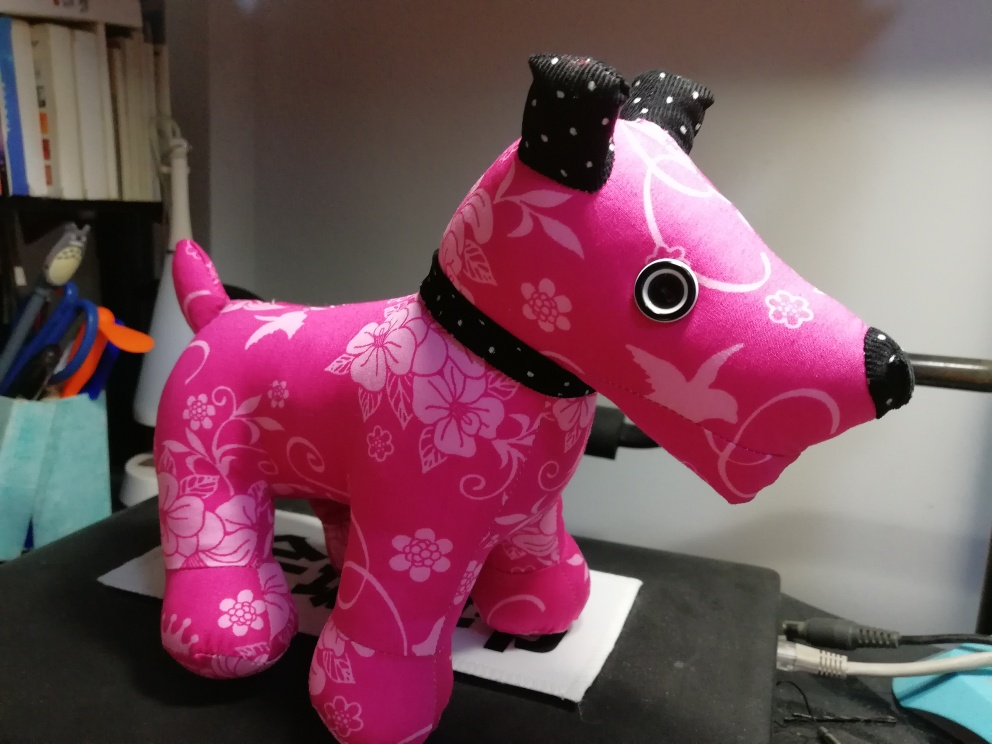Could you describe the design elements seen on this object? Certainly! The object features a floral motif with various flower shapes in a lighter shade of pink set against a darker pink background. The contrast of the patterns creates a visually engaging appearance. Additionally, the collar has a studded embellishment that adds a touch of texture and character. 